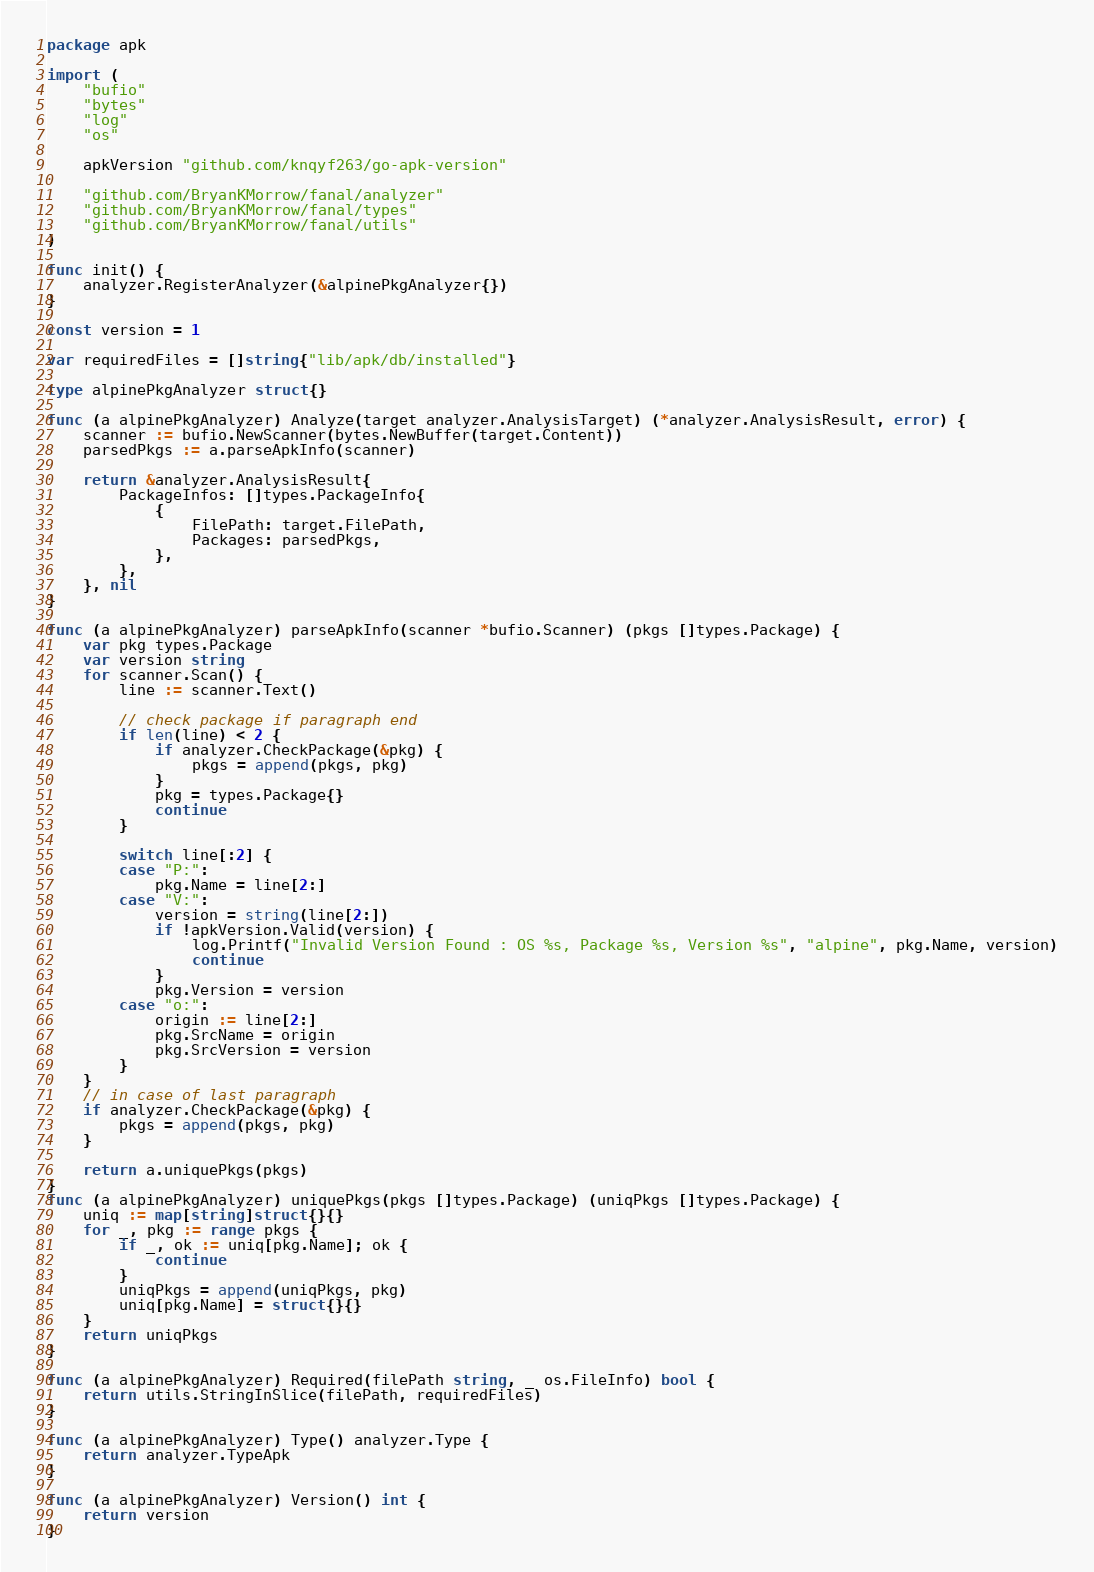Convert code to text. <code><loc_0><loc_0><loc_500><loc_500><_Go_>package apk

import (
	"bufio"
	"bytes"
	"log"
	"os"

	apkVersion "github.com/knqyf263/go-apk-version"

	"github.com/BryanKMorrow/fanal/analyzer"
	"github.com/BryanKMorrow/fanal/types"
	"github.com/BryanKMorrow/fanal/utils"
)

func init() {
	analyzer.RegisterAnalyzer(&alpinePkgAnalyzer{})
}

const version = 1

var requiredFiles = []string{"lib/apk/db/installed"}

type alpinePkgAnalyzer struct{}

func (a alpinePkgAnalyzer) Analyze(target analyzer.AnalysisTarget) (*analyzer.AnalysisResult, error) {
	scanner := bufio.NewScanner(bytes.NewBuffer(target.Content))
	parsedPkgs := a.parseApkInfo(scanner)

	return &analyzer.AnalysisResult{
		PackageInfos: []types.PackageInfo{
			{
				FilePath: target.FilePath,
				Packages: parsedPkgs,
			},
		},
	}, nil
}

func (a alpinePkgAnalyzer) parseApkInfo(scanner *bufio.Scanner) (pkgs []types.Package) {
	var pkg types.Package
	var version string
	for scanner.Scan() {
		line := scanner.Text()

		// check package if paragraph end
		if len(line) < 2 {
			if analyzer.CheckPackage(&pkg) {
				pkgs = append(pkgs, pkg)
			}
			pkg = types.Package{}
			continue
		}

		switch line[:2] {
		case "P:":
			pkg.Name = line[2:]
		case "V:":
			version = string(line[2:])
			if !apkVersion.Valid(version) {
				log.Printf("Invalid Version Found : OS %s, Package %s, Version %s", "alpine", pkg.Name, version)
				continue
			}
			pkg.Version = version
		case "o:":
			origin := line[2:]
			pkg.SrcName = origin
			pkg.SrcVersion = version
		}
	}
	// in case of last paragraph
	if analyzer.CheckPackage(&pkg) {
		pkgs = append(pkgs, pkg)
	}

	return a.uniquePkgs(pkgs)
}
func (a alpinePkgAnalyzer) uniquePkgs(pkgs []types.Package) (uniqPkgs []types.Package) {
	uniq := map[string]struct{}{}
	for _, pkg := range pkgs {
		if _, ok := uniq[pkg.Name]; ok {
			continue
		}
		uniqPkgs = append(uniqPkgs, pkg)
		uniq[pkg.Name] = struct{}{}
	}
	return uniqPkgs
}

func (a alpinePkgAnalyzer) Required(filePath string, _ os.FileInfo) bool {
	return utils.StringInSlice(filePath, requiredFiles)
}

func (a alpinePkgAnalyzer) Type() analyzer.Type {
	return analyzer.TypeApk
}

func (a alpinePkgAnalyzer) Version() int {
	return version
}
</code> 